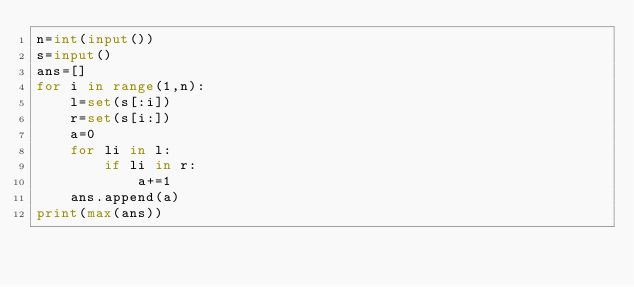Convert code to text. <code><loc_0><loc_0><loc_500><loc_500><_Python_>n=int(input())
s=input()
ans=[]
for i in range(1,n):
    l=set(s[:i])
    r=set(s[i:])
    a=0
    for li in l:
        if li in r:
            a+=1
    ans.append(a)
print(max(ans))
</code> 